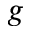Convert formula to latex. <formula><loc_0><loc_0><loc_500><loc_500>g</formula> 